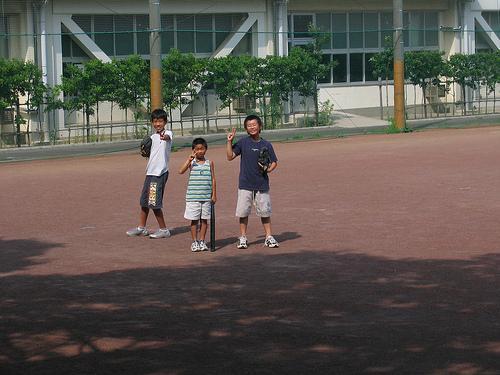How many people are there?
Give a very brief answer. 3. 